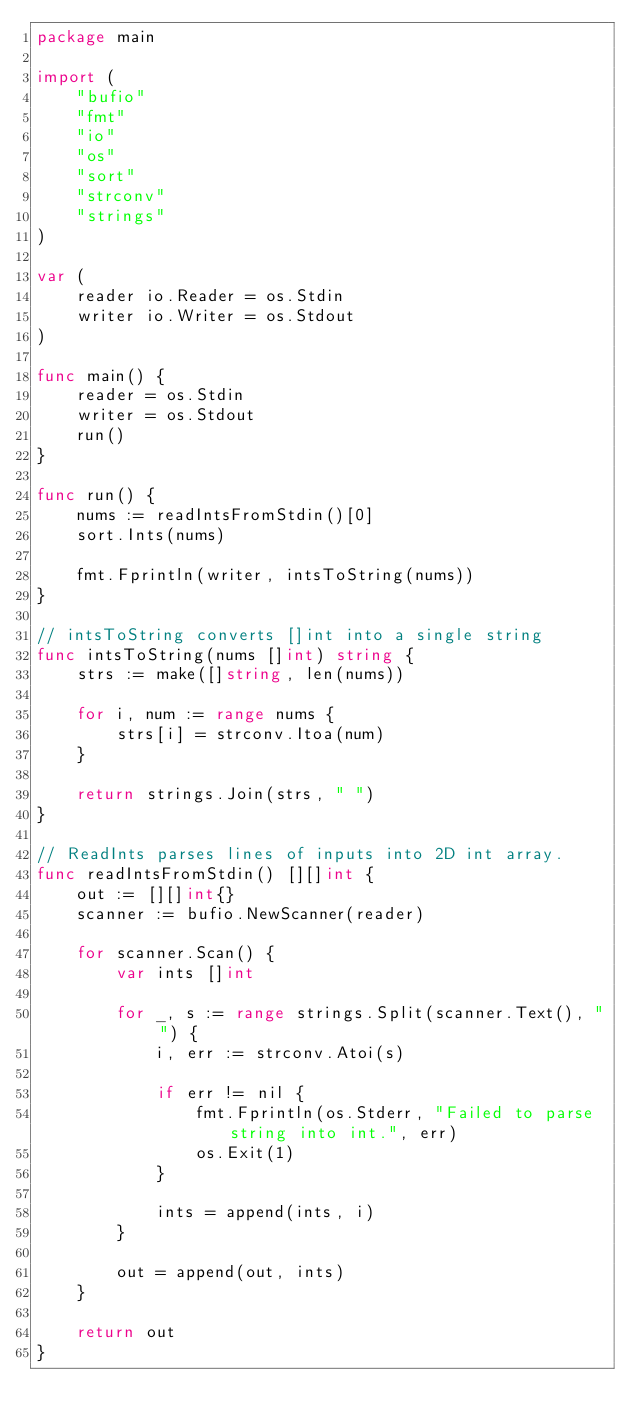<code> <loc_0><loc_0><loc_500><loc_500><_Go_>package main

import (
	"bufio"
	"fmt"
	"io"
	"os"
	"sort"
	"strconv"
	"strings"
)

var (
	reader io.Reader = os.Stdin
	writer io.Writer = os.Stdout
)

func main() {
	reader = os.Stdin
	writer = os.Stdout
	run()
}

func run() {
	nums := readIntsFromStdin()[0]
	sort.Ints(nums)

	fmt.Fprintln(writer, intsToString(nums))
}

// intsToString converts []int into a single string
func intsToString(nums []int) string {
	strs := make([]string, len(nums))

	for i, num := range nums {
		strs[i] = strconv.Itoa(num)
	}

	return strings.Join(strs, " ")
}

// ReadInts parses lines of inputs into 2D int array.
func readIntsFromStdin() [][]int {
	out := [][]int{}
	scanner := bufio.NewScanner(reader)

	for scanner.Scan() {
		var ints []int

		for _, s := range strings.Split(scanner.Text(), " ") {
			i, err := strconv.Atoi(s)

			if err != nil {
				fmt.Fprintln(os.Stderr, "Failed to parse string into int.", err)
				os.Exit(1)
			}

			ints = append(ints, i)
		}

		out = append(out, ints)
	}

	return out
}

</code> 